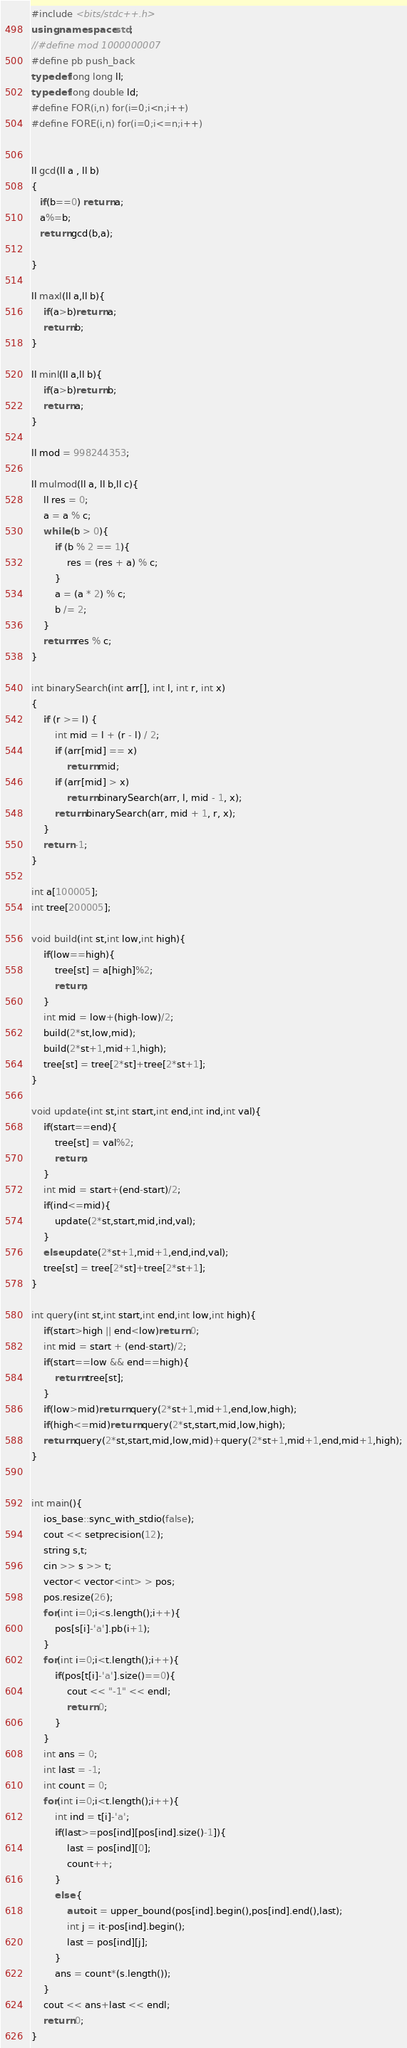<code> <loc_0><loc_0><loc_500><loc_500><_C++_>#include <bits/stdc++.h>
using namespace std;
//#define mod 1000000007
#define pb push_back
typedef long long ll;
typedef long double ld;
#define FOR(i,n) for(i=0;i<n;i++)
#define FORE(i,n) for(i=0;i<=n;i++)
 
 
ll gcd(ll a , ll b)
{
   if(b==0) return a;
   a%=b;
   return gcd(b,a);
   
}
    
ll maxl(ll a,ll b){
    if(a>b)return a;
    return b;
}
 
ll minl(ll a,ll b){
    if(a>b)return b;
    return a;
}
 
ll mod = 998244353;
 
ll mulmod(ll a, ll b,ll c){ 
    ll res = 0; 
    a = a % c; 
    while (b > 0){ 
        if (b % 2 == 1){ 
            res = (res + a) % c;
        }
        a = (a * 2) % c; 
        b /= 2; 
    } 
    return res % c; 
}
 
int binarySearch(int arr[], int l, int r, int x) 
{ 
    if (r >= l) { 
        int mid = l + (r - l) / 2; 
        if (arr[mid] == x) 
            return mid; 
        if (arr[mid] > x) 
            return binarySearch(arr, l, mid - 1, x); 
        return binarySearch(arr, mid + 1, r, x); 
    } 
    return -1; 
} 
 
int a[100005];
int tree[200005];
 
void build(int st,int low,int high){
    if(low==high){
        tree[st] = a[high]%2;
        return;
    }
    int mid = low+(high-low)/2;
    build(2*st,low,mid);
    build(2*st+1,mid+1,high);
    tree[st] = tree[2*st]+tree[2*st+1];
}
 
void update(int st,int start,int end,int ind,int val){
    if(start==end){
        tree[st] = val%2;
        return;
    }
    int mid = start+(end-start)/2;
    if(ind<=mid){
        update(2*st,start,mid,ind,val);
    }
    else update(2*st+1,mid+1,end,ind,val);
    tree[st] = tree[2*st]+tree[2*st+1];
}
 
int query(int st,int start,int end,int low,int high){
    if(start>high || end<low)return 0;
    int mid = start + (end-start)/2;
    if(start==low && end==high){
        return tree[st];
    }
    if(low>mid)return query(2*st+1,mid+1,end,low,high);
    if(high<=mid)return query(2*st,start,mid,low,high);
    return query(2*st,start,mid,low,mid)+query(2*st+1,mid+1,end,mid+1,high);
}


int main(){
	ios_base::sync_with_stdio(false);
	cout << setprecision(12);
    string s,t;
    cin >> s >> t;
    vector< vector<int> > pos;
    pos.resize(26);
    for(int i=0;i<s.length();i++){
        pos[s[i]-'a'].pb(i+1);
    }
    for(int i=0;i<t.length();i++){
        if(pos[t[i]-'a'].size()==0){
            cout << "-1" << endl;
            return 0;
        }
    }
    int ans = 0;
    int last = -1;
    int count = 0;
    for(int i=0;i<t.length();i++){
        int ind = t[i]-'a';
        if(last>=pos[ind][pos[ind].size()-1]){
            last = pos[ind][0];
            count++;
        }
        else {
            auto it = upper_bound(pos[ind].begin(),pos[ind].end(),last);
            int j = it-pos[ind].begin();
            last = pos[ind][j];
        }
        ans = count*(s.length());
    }
    cout << ans+last << endl;
	return 0;
}
</code> 